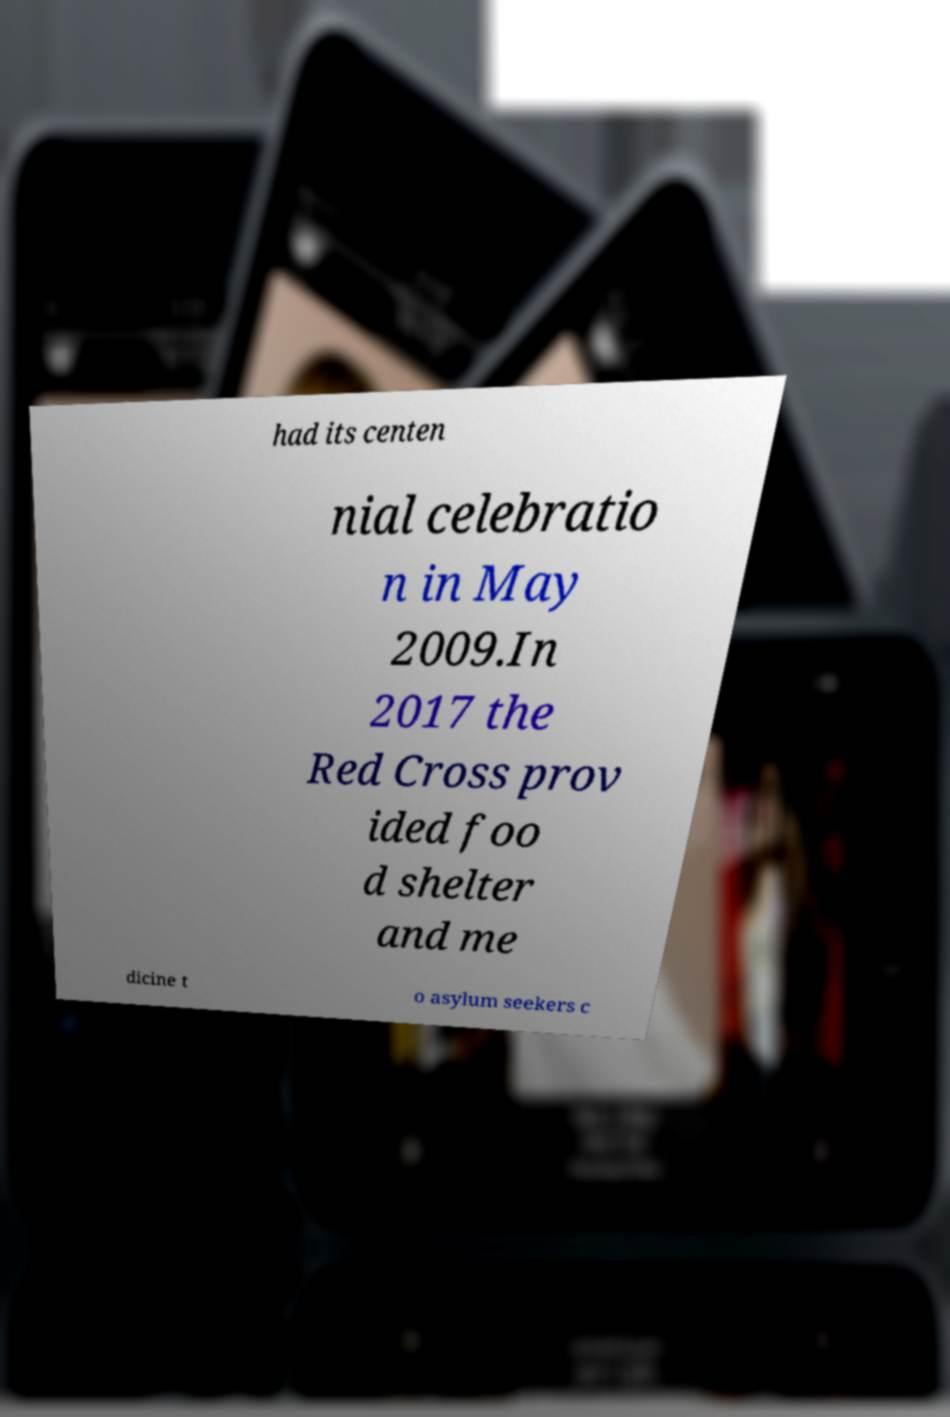For documentation purposes, I need the text within this image transcribed. Could you provide that? had its centen nial celebratio n in May 2009.In 2017 the Red Cross prov ided foo d shelter and me dicine t o asylum seekers c 